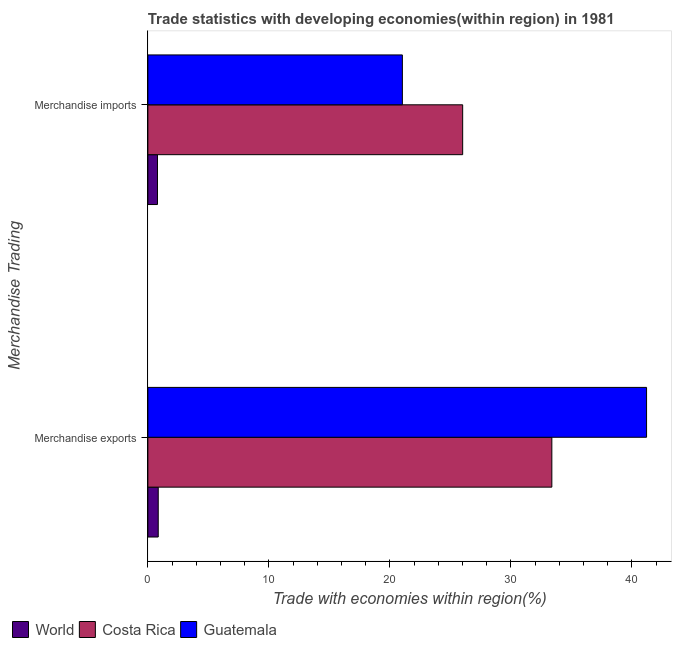How many different coloured bars are there?
Provide a succinct answer. 3. Are the number of bars per tick equal to the number of legend labels?
Ensure brevity in your answer.  Yes. Are the number of bars on each tick of the Y-axis equal?
Ensure brevity in your answer.  Yes. What is the merchandise exports in Costa Rica?
Your answer should be very brief. 33.38. Across all countries, what is the maximum merchandise exports?
Give a very brief answer. 41.21. Across all countries, what is the minimum merchandise imports?
Provide a succinct answer. 0.79. In which country was the merchandise exports maximum?
Make the answer very short. Guatemala. What is the total merchandise exports in the graph?
Your answer should be very brief. 75.45. What is the difference between the merchandise imports in Costa Rica and that in Guatemala?
Offer a terse response. 4.98. What is the difference between the merchandise exports in Costa Rica and the merchandise imports in World?
Your answer should be very brief. 32.59. What is the average merchandise imports per country?
Ensure brevity in your answer.  15.95. What is the difference between the merchandise imports and merchandise exports in Guatemala?
Offer a terse response. -20.18. What is the ratio of the merchandise exports in Guatemala to that in World?
Make the answer very short. 48.11. Is the merchandise imports in Costa Rica less than that in World?
Give a very brief answer. No. What does the 1st bar from the top in Merchandise exports represents?
Keep it short and to the point. Guatemala. What does the 1st bar from the bottom in Merchandise imports represents?
Provide a succinct answer. World. How many bars are there?
Offer a very short reply. 6. Are all the bars in the graph horizontal?
Your answer should be very brief. Yes. How many legend labels are there?
Offer a terse response. 3. How are the legend labels stacked?
Your answer should be very brief. Horizontal. What is the title of the graph?
Keep it short and to the point. Trade statistics with developing economies(within region) in 1981. Does "India" appear as one of the legend labels in the graph?
Offer a very short reply. No. What is the label or title of the X-axis?
Provide a short and direct response. Trade with economies within region(%). What is the label or title of the Y-axis?
Your answer should be very brief. Merchandise Trading. What is the Trade with economies within region(%) of World in Merchandise exports?
Your answer should be compact. 0.86. What is the Trade with economies within region(%) in Costa Rica in Merchandise exports?
Your answer should be very brief. 33.38. What is the Trade with economies within region(%) in Guatemala in Merchandise exports?
Provide a short and direct response. 41.21. What is the Trade with economies within region(%) of World in Merchandise imports?
Provide a short and direct response. 0.79. What is the Trade with economies within region(%) of Costa Rica in Merchandise imports?
Provide a short and direct response. 26.01. What is the Trade with economies within region(%) of Guatemala in Merchandise imports?
Provide a succinct answer. 21.03. Across all Merchandise Trading, what is the maximum Trade with economies within region(%) in World?
Your answer should be compact. 0.86. Across all Merchandise Trading, what is the maximum Trade with economies within region(%) of Costa Rica?
Ensure brevity in your answer.  33.38. Across all Merchandise Trading, what is the maximum Trade with economies within region(%) of Guatemala?
Your answer should be very brief. 41.21. Across all Merchandise Trading, what is the minimum Trade with economies within region(%) in World?
Ensure brevity in your answer.  0.79. Across all Merchandise Trading, what is the minimum Trade with economies within region(%) in Costa Rica?
Offer a terse response. 26.01. Across all Merchandise Trading, what is the minimum Trade with economies within region(%) of Guatemala?
Give a very brief answer. 21.03. What is the total Trade with economies within region(%) in World in the graph?
Ensure brevity in your answer.  1.65. What is the total Trade with economies within region(%) of Costa Rica in the graph?
Offer a terse response. 59.4. What is the total Trade with economies within region(%) in Guatemala in the graph?
Keep it short and to the point. 62.24. What is the difference between the Trade with economies within region(%) in World in Merchandise exports and that in Merchandise imports?
Offer a terse response. 0.06. What is the difference between the Trade with economies within region(%) of Costa Rica in Merchandise exports and that in Merchandise imports?
Ensure brevity in your answer.  7.37. What is the difference between the Trade with economies within region(%) in Guatemala in Merchandise exports and that in Merchandise imports?
Your answer should be very brief. 20.18. What is the difference between the Trade with economies within region(%) of World in Merchandise exports and the Trade with economies within region(%) of Costa Rica in Merchandise imports?
Provide a short and direct response. -25.16. What is the difference between the Trade with economies within region(%) in World in Merchandise exports and the Trade with economies within region(%) in Guatemala in Merchandise imports?
Ensure brevity in your answer.  -20.18. What is the difference between the Trade with economies within region(%) of Costa Rica in Merchandise exports and the Trade with economies within region(%) of Guatemala in Merchandise imports?
Provide a succinct answer. 12.35. What is the average Trade with economies within region(%) in World per Merchandise Trading?
Give a very brief answer. 0.83. What is the average Trade with economies within region(%) in Costa Rica per Merchandise Trading?
Make the answer very short. 29.7. What is the average Trade with economies within region(%) in Guatemala per Merchandise Trading?
Your answer should be compact. 31.12. What is the difference between the Trade with economies within region(%) of World and Trade with economies within region(%) of Costa Rica in Merchandise exports?
Ensure brevity in your answer.  -32.53. What is the difference between the Trade with economies within region(%) in World and Trade with economies within region(%) in Guatemala in Merchandise exports?
Offer a terse response. -40.35. What is the difference between the Trade with economies within region(%) of Costa Rica and Trade with economies within region(%) of Guatemala in Merchandise exports?
Provide a succinct answer. -7.83. What is the difference between the Trade with economies within region(%) of World and Trade with economies within region(%) of Costa Rica in Merchandise imports?
Keep it short and to the point. -25.22. What is the difference between the Trade with economies within region(%) in World and Trade with economies within region(%) in Guatemala in Merchandise imports?
Offer a very short reply. -20.24. What is the difference between the Trade with economies within region(%) in Costa Rica and Trade with economies within region(%) in Guatemala in Merchandise imports?
Your answer should be compact. 4.98. What is the ratio of the Trade with economies within region(%) of World in Merchandise exports to that in Merchandise imports?
Make the answer very short. 1.08. What is the ratio of the Trade with economies within region(%) of Costa Rica in Merchandise exports to that in Merchandise imports?
Offer a very short reply. 1.28. What is the ratio of the Trade with economies within region(%) in Guatemala in Merchandise exports to that in Merchandise imports?
Offer a terse response. 1.96. What is the difference between the highest and the second highest Trade with economies within region(%) of World?
Keep it short and to the point. 0.06. What is the difference between the highest and the second highest Trade with economies within region(%) of Costa Rica?
Offer a terse response. 7.37. What is the difference between the highest and the second highest Trade with economies within region(%) in Guatemala?
Your response must be concise. 20.18. What is the difference between the highest and the lowest Trade with economies within region(%) in World?
Keep it short and to the point. 0.06. What is the difference between the highest and the lowest Trade with economies within region(%) in Costa Rica?
Keep it short and to the point. 7.37. What is the difference between the highest and the lowest Trade with economies within region(%) of Guatemala?
Provide a succinct answer. 20.18. 